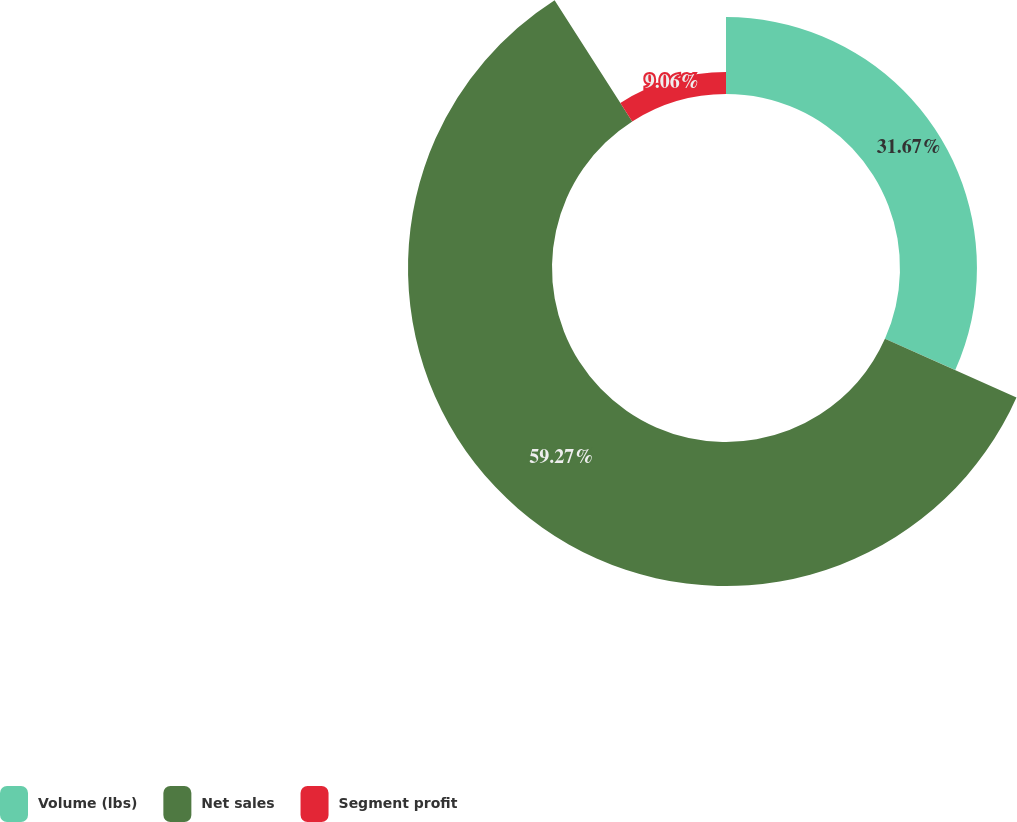Convert chart to OTSL. <chart><loc_0><loc_0><loc_500><loc_500><pie_chart><fcel>Volume (lbs)<fcel>Net sales<fcel>Segment profit<nl><fcel>31.67%<fcel>59.27%<fcel>9.06%<nl></chart> 